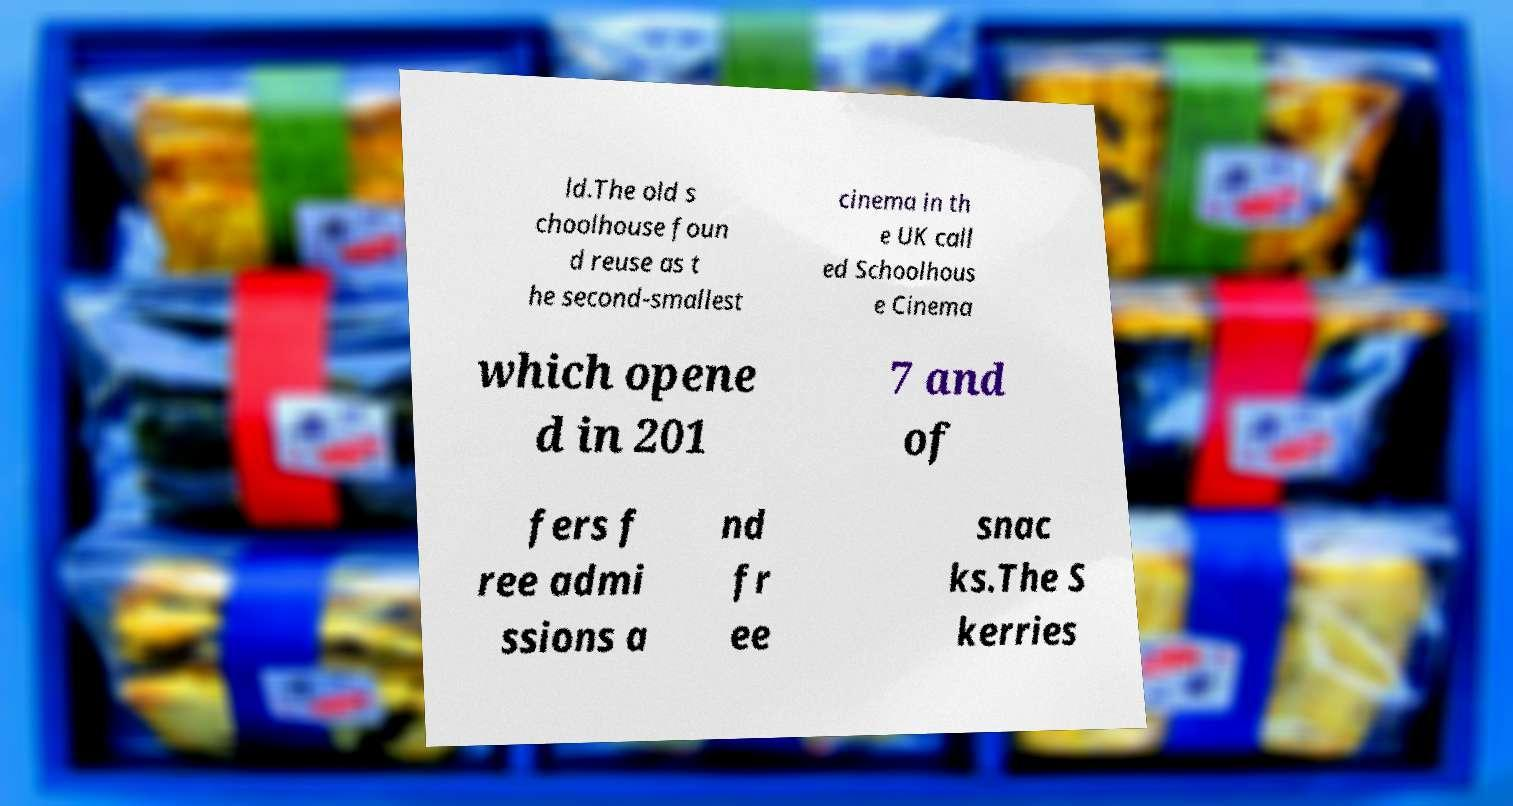Could you extract and type out the text from this image? ld.The old s choolhouse foun d reuse as t he second-smallest cinema in th e UK call ed Schoolhous e Cinema which opene d in 201 7 and of fers f ree admi ssions a nd fr ee snac ks.The S kerries 